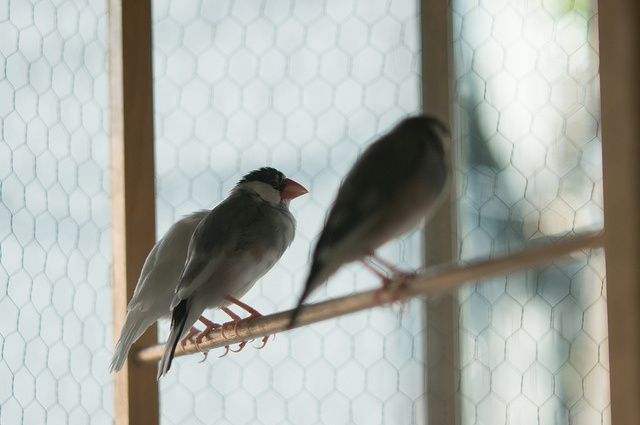Describe the objects in this image and their specific colors. I can see bird in lightgray, black, gray, and darkgray tones, bird in lightgray, black, gray, and maroon tones, and bird in lightgray, gray, black, and darkgray tones in this image. 